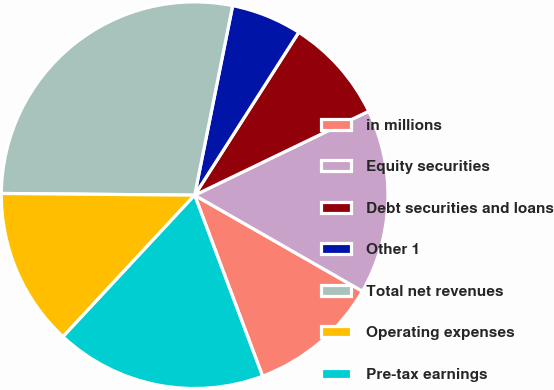Convert chart to OTSL. <chart><loc_0><loc_0><loc_500><loc_500><pie_chart><fcel>in millions<fcel>Equity securities<fcel>Debt securities and loans<fcel>Other 1<fcel>Total net revenues<fcel>Operating expenses<fcel>Pre-tax earnings<nl><fcel>11.01%<fcel>15.43%<fcel>8.8%<fcel>5.9%<fcel>28.01%<fcel>13.22%<fcel>17.64%<nl></chart> 